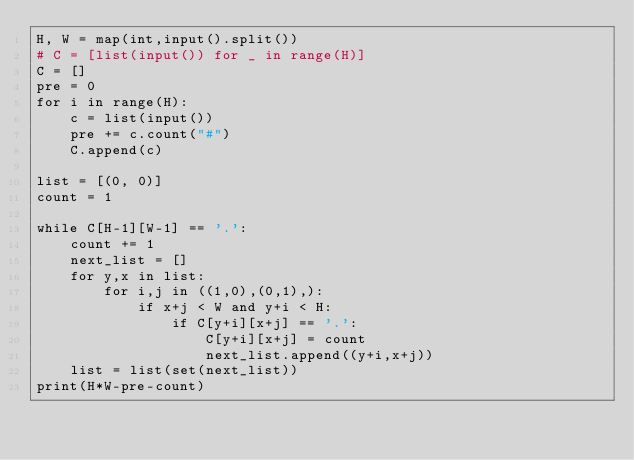<code> <loc_0><loc_0><loc_500><loc_500><_Python_>H, W = map(int,input().split())
# C = [list(input()) for _ in range(H)]
C = []
pre = 0
for i in range(H):
    c = list(input())
    pre += c.count("#")
    C.append(c)

list = [(0, 0)]
count = 1
 
while C[H-1][W-1] == '.':
    count += 1
    next_list = []
    for y,x in list:
        for i,j in ((1,0),(0,1),):
            if x+j < W and y+i < H:
                if C[y+i][x+j] == '.':
                    C[y+i][x+j] = count
                    next_list.append((y+i,x+j))
    list = list(set(next_list))
print(H*W-pre-count)</code> 